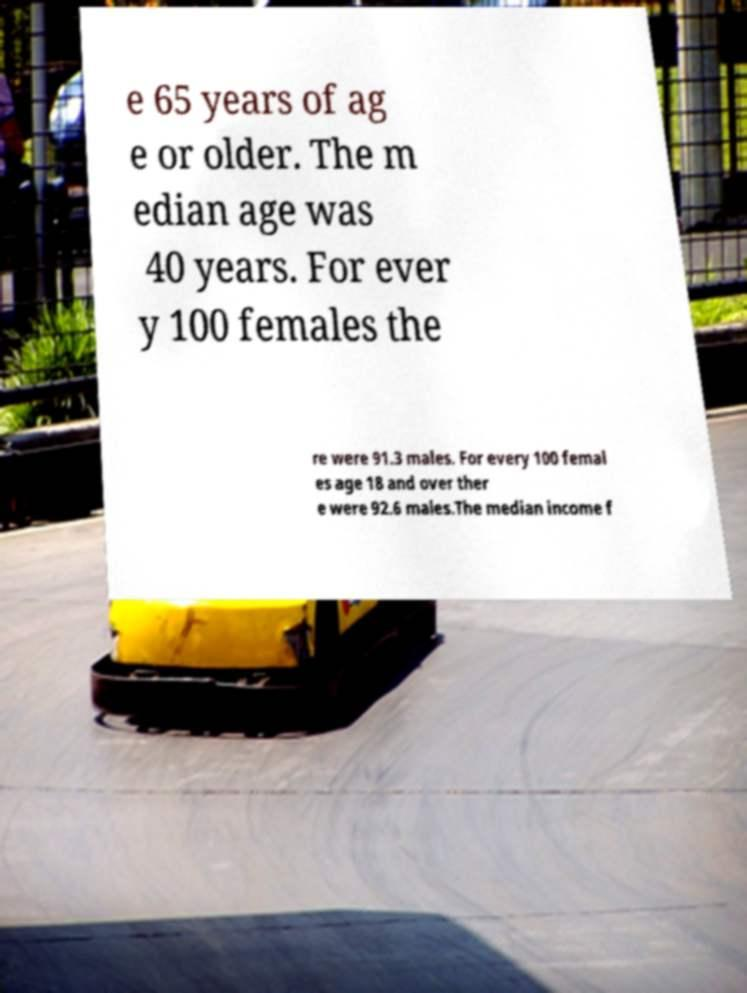Could you assist in decoding the text presented in this image and type it out clearly? e 65 years of ag e or older. The m edian age was 40 years. For ever y 100 females the re were 91.3 males. For every 100 femal es age 18 and over ther e were 92.6 males.The median income f 